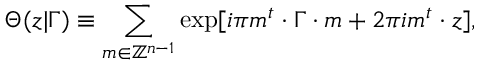<formula> <loc_0><loc_0><loc_500><loc_500>\Theta ( z | \Gamma ) \equiv \sum _ { m \in \mathbb { Z } ^ { n - 1 } } \exp [ i \pi m ^ { t } \cdot \Gamma \cdot m + 2 \pi i m ^ { t } \cdot z ] ,</formula> 